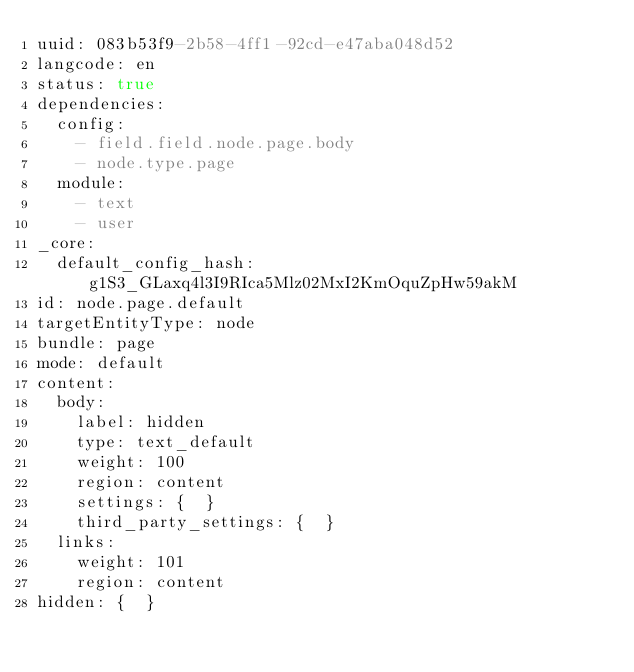<code> <loc_0><loc_0><loc_500><loc_500><_YAML_>uuid: 083b53f9-2b58-4ff1-92cd-e47aba048d52
langcode: en
status: true
dependencies:
  config:
    - field.field.node.page.body
    - node.type.page
  module:
    - text
    - user
_core:
  default_config_hash: g1S3_GLaxq4l3I9RIca5Mlz02MxI2KmOquZpHw59akM
id: node.page.default
targetEntityType: node
bundle: page
mode: default
content:
  body:
    label: hidden
    type: text_default
    weight: 100
    region: content
    settings: {  }
    third_party_settings: {  }
  links:
    weight: 101
    region: content
hidden: {  }
</code> 